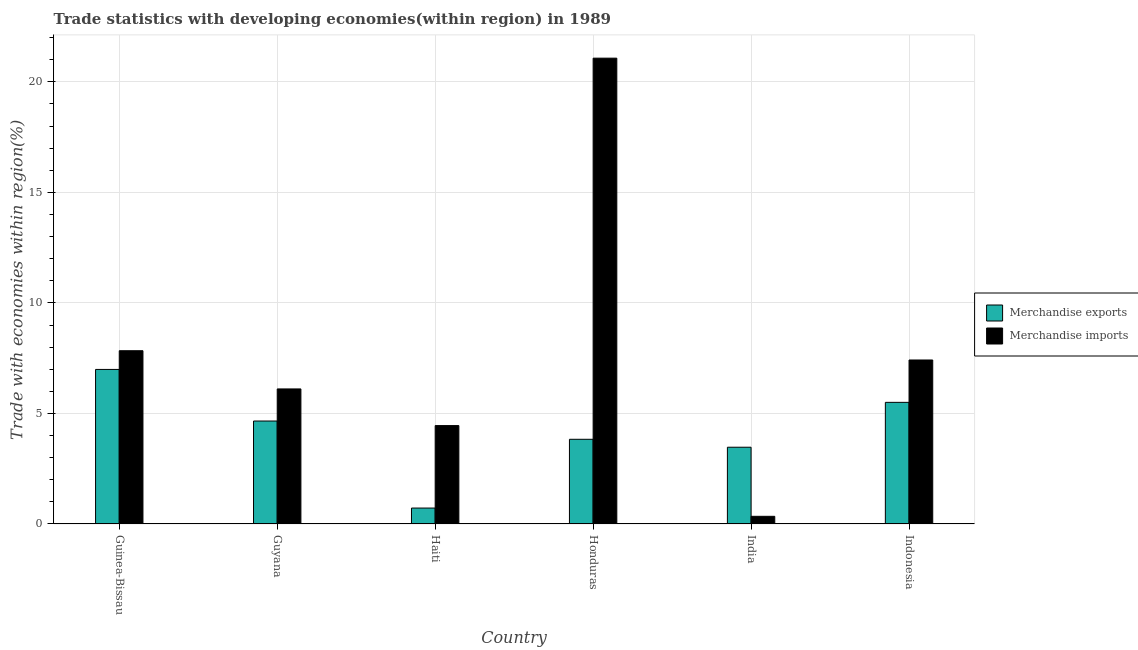Are the number of bars per tick equal to the number of legend labels?
Your response must be concise. Yes. How many bars are there on the 4th tick from the left?
Keep it short and to the point. 2. What is the label of the 6th group of bars from the left?
Your response must be concise. Indonesia. What is the merchandise exports in Guyana?
Give a very brief answer. 4.66. Across all countries, what is the maximum merchandise exports?
Your response must be concise. 6.99. Across all countries, what is the minimum merchandise exports?
Give a very brief answer. 0.72. In which country was the merchandise exports maximum?
Provide a short and direct response. Guinea-Bissau. In which country was the merchandise exports minimum?
Provide a succinct answer. Haiti. What is the total merchandise exports in the graph?
Ensure brevity in your answer.  25.17. What is the difference between the merchandise imports in Guyana and that in Haiti?
Offer a terse response. 1.66. What is the difference between the merchandise exports in Indonesia and the merchandise imports in Guinea-Bissau?
Make the answer very short. -2.34. What is the average merchandise imports per country?
Provide a short and direct response. 7.87. What is the difference between the merchandise imports and merchandise exports in Indonesia?
Your response must be concise. 1.92. What is the ratio of the merchandise imports in Guinea-Bissau to that in Haiti?
Offer a very short reply. 1.76. Is the difference between the merchandise exports in Haiti and Indonesia greater than the difference between the merchandise imports in Haiti and Indonesia?
Keep it short and to the point. No. What is the difference between the highest and the second highest merchandise imports?
Your response must be concise. 13.23. What is the difference between the highest and the lowest merchandise imports?
Provide a short and direct response. 20.72. Is the sum of the merchandise exports in India and Indonesia greater than the maximum merchandise imports across all countries?
Ensure brevity in your answer.  No. How many bars are there?
Your answer should be very brief. 12. Does the graph contain any zero values?
Keep it short and to the point. No. Does the graph contain grids?
Make the answer very short. Yes. Where does the legend appear in the graph?
Give a very brief answer. Center right. What is the title of the graph?
Your response must be concise. Trade statistics with developing economies(within region) in 1989. Does "Male labor force" appear as one of the legend labels in the graph?
Make the answer very short. No. What is the label or title of the X-axis?
Make the answer very short. Country. What is the label or title of the Y-axis?
Make the answer very short. Trade with economies within region(%). What is the Trade with economies within region(%) of Merchandise exports in Guinea-Bissau?
Ensure brevity in your answer.  6.99. What is the Trade with economies within region(%) of Merchandise imports in Guinea-Bissau?
Provide a short and direct response. 7.84. What is the Trade with economies within region(%) of Merchandise exports in Guyana?
Your answer should be very brief. 4.66. What is the Trade with economies within region(%) in Merchandise imports in Guyana?
Provide a short and direct response. 6.11. What is the Trade with economies within region(%) in Merchandise exports in Haiti?
Make the answer very short. 0.72. What is the Trade with economies within region(%) in Merchandise imports in Haiti?
Offer a terse response. 4.45. What is the Trade with economies within region(%) in Merchandise exports in Honduras?
Provide a short and direct response. 3.83. What is the Trade with economies within region(%) in Merchandise imports in Honduras?
Make the answer very short. 21.07. What is the Trade with economies within region(%) of Merchandise exports in India?
Your answer should be very brief. 3.47. What is the Trade with economies within region(%) of Merchandise imports in India?
Your answer should be compact. 0.35. What is the Trade with economies within region(%) in Merchandise exports in Indonesia?
Your answer should be compact. 5.5. What is the Trade with economies within region(%) of Merchandise imports in Indonesia?
Your answer should be compact. 7.42. Across all countries, what is the maximum Trade with economies within region(%) in Merchandise exports?
Provide a succinct answer. 6.99. Across all countries, what is the maximum Trade with economies within region(%) in Merchandise imports?
Your response must be concise. 21.07. Across all countries, what is the minimum Trade with economies within region(%) of Merchandise exports?
Offer a very short reply. 0.72. Across all countries, what is the minimum Trade with economies within region(%) in Merchandise imports?
Offer a very short reply. 0.35. What is the total Trade with economies within region(%) in Merchandise exports in the graph?
Your response must be concise. 25.17. What is the total Trade with economies within region(%) in Merchandise imports in the graph?
Ensure brevity in your answer.  47.23. What is the difference between the Trade with economies within region(%) of Merchandise exports in Guinea-Bissau and that in Guyana?
Give a very brief answer. 2.33. What is the difference between the Trade with economies within region(%) in Merchandise imports in Guinea-Bissau and that in Guyana?
Provide a succinct answer. 1.73. What is the difference between the Trade with economies within region(%) of Merchandise exports in Guinea-Bissau and that in Haiti?
Your response must be concise. 6.27. What is the difference between the Trade with economies within region(%) in Merchandise imports in Guinea-Bissau and that in Haiti?
Ensure brevity in your answer.  3.39. What is the difference between the Trade with economies within region(%) of Merchandise exports in Guinea-Bissau and that in Honduras?
Provide a succinct answer. 3.16. What is the difference between the Trade with economies within region(%) of Merchandise imports in Guinea-Bissau and that in Honduras?
Your response must be concise. -13.23. What is the difference between the Trade with economies within region(%) in Merchandise exports in Guinea-Bissau and that in India?
Provide a succinct answer. 3.52. What is the difference between the Trade with economies within region(%) in Merchandise imports in Guinea-Bissau and that in India?
Make the answer very short. 7.49. What is the difference between the Trade with economies within region(%) in Merchandise exports in Guinea-Bissau and that in Indonesia?
Offer a very short reply. 1.49. What is the difference between the Trade with economies within region(%) of Merchandise imports in Guinea-Bissau and that in Indonesia?
Offer a terse response. 0.42. What is the difference between the Trade with economies within region(%) of Merchandise exports in Guyana and that in Haiti?
Make the answer very short. 3.94. What is the difference between the Trade with economies within region(%) of Merchandise imports in Guyana and that in Haiti?
Give a very brief answer. 1.66. What is the difference between the Trade with economies within region(%) in Merchandise exports in Guyana and that in Honduras?
Give a very brief answer. 0.83. What is the difference between the Trade with economies within region(%) in Merchandise imports in Guyana and that in Honduras?
Your answer should be very brief. -14.96. What is the difference between the Trade with economies within region(%) in Merchandise exports in Guyana and that in India?
Your answer should be very brief. 1.19. What is the difference between the Trade with economies within region(%) of Merchandise imports in Guyana and that in India?
Your answer should be very brief. 5.76. What is the difference between the Trade with economies within region(%) of Merchandise exports in Guyana and that in Indonesia?
Ensure brevity in your answer.  -0.84. What is the difference between the Trade with economies within region(%) in Merchandise imports in Guyana and that in Indonesia?
Provide a short and direct response. -1.31. What is the difference between the Trade with economies within region(%) of Merchandise exports in Haiti and that in Honduras?
Provide a short and direct response. -3.11. What is the difference between the Trade with economies within region(%) of Merchandise imports in Haiti and that in Honduras?
Offer a very short reply. -16.62. What is the difference between the Trade with economies within region(%) of Merchandise exports in Haiti and that in India?
Give a very brief answer. -2.75. What is the difference between the Trade with economies within region(%) in Merchandise imports in Haiti and that in India?
Provide a short and direct response. 4.1. What is the difference between the Trade with economies within region(%) of Merchandise exports in Haiti and that in Indonesia?
Offer a very short reply. -4.78. What is the difference between the Trade with economies within region(%) of Merchandise imports in Haiti and that in Indonesia?
Make the answer very short. -2.97. What is the difference between the Trade with economies within region(%) in Merchandise exports in Honduras and that in India?
Your answer should be compact. 0.36. What is the difference between the Trade with economies within region(%) in Merchandise imports in Honduras and that in India?
Offer a very short reply. 20.72. What is the difference between the Trade with economies within region(%) in Merchandise exports in Honduras and that in Indonesia?
Offer a terse response. -1.67. What is the difference between the Trade with economies within region(%) of Merchandise imports in Honduras and that in Indonesia?
Your answer should be very brief. 13.65. What is the difference between the Trade with economies within region(%) in Merchandise exports in India and that in Indonesia?
Give a very brief answer. -2.03. What is the difference between the Trade with economies within region(%) in Merchandise imports in India and that in Indonesia?
Your answer should be compact. -7.07. What is the difference between the Trade with economies within region(%) in Merchandise exports in Guinea-Bissau and the Trade with economies within region(%) in Merchandise imports in Guyana?
Provide a short and direct response. 0.88. What is the difference between the Trade with economies within region(%) of Merchandise exports in Guinea-Bissau and the Trade with economies within region(%) of Merchandise imports in Haiti?
Offer a very short reply. 2.54. What is the difference between the Trade with economies within region(%) of Merchandise exports in Guinea-Bissau and the Trade with economies within region(%) of Merchandise imports in Honduras?
Your response must be concise. -14.08. What is the difference between the Trade with economies within region(%) of Merchandise exports in Guinea-Bissau and the Trade with economies within region(%) of Merchandise imports in India?
Make the answer very short. 6.64. What is the difference between the Trade with economies within region(%) of Merchandise exports in Guinea-Bissau and the Trade with economies within region(%) of Merchandise imports in Indonesia?
Ensure brevity in your answer.  -0.43. What is the difference between the Trade with economies within region(%) in Merchandise exports in Guyana and the Trade with economies within region(%) in Merchandise imports in Haiti?
Provide a succinct answer. 0.21. What is the difference between the Trade with economies within region(%) in Merchandise exports in Guyana and the Trade with economies within region(%) in Merchandise imports in Honduras?
Your response must be concise. -16.41. What is the difference between the Trade with economies within region(%) in Merchandise exports in Guyana and the Trade with economies within region(%) in Merchandise imports in India?
Make the answer very short. 4.31. What is the difference between the Trade with economies within region(%) in Merchandise exports in Guyana and the Trade with economies within region(%) in Merchandise imports in Indonesia?
Give a very brief answer. -2.76. What is the difference between the Trade with economies within region(%) in Merchandise exports in Haiti and the Trade with economies within region(%) in Merchandise imports in Honduras?
Ensure brevity in your answer.  -20.35. What is the difference between the Trade with economies within region(%) of Merchandise exports in Haiti and the Trade with economies within region(%) of Merchandise imports in India?
Your answer should be compact. 0.37. What is the difference between the Trade with economies within region(%) in Merchandise exports in Haiti and the Trade with economies within region(%) in Merchandise imports in Indonesia?
Your answer should be compact. -6.7. What is the difference between the Trade with economies within region(%) in Merchandise exports in Honduras and the Trade with economies within region(%) in Merchandise imports in India?
Offer a terse response. 3.48. What is the difference between the Trade with economies within region(%) of Merchandise exports in Honduras and the Trade with economies within region(%) of Merchandise imports in Indonesia?
Make the answer very short. -3.59. What is the difference between the Trade with economies within region(%) in Merchandise exports in India and the Trade with economies within region(%) in Merchandise imports in Indonesia?
Provide a short and direct response. -3.95. What is the average Trade with economies within region(%) of Merchandise exports per country?
Offer a terse response. 4.2. What is the average Trade with economies within region(%) of Merchandise imports per country?
Your response must be concise. 7.87. What is the difference between the Trade with economies within region(%) in Merchandise exports and Trade with economies within region(%) in Merchandise imports in Guinea-Bissau?
Keep it short and to the point. -0.85. What is the difference between the Trade with economies within region(%) in Merchandise exports and Trade with economies within region(%) in Merchandise imports in Guyana?
Provide a short and direct response. -1.45. What is the difference between the Trade with economies within region(%) of Merchandise exports and Trade with economies within region(%) of Merchandise imports in Haiti?
Ensure brevity in your answer.  -3.73. What is the difference between the Trade with economies within region(%) of Merchandise exports and Trade with economies within region(%) of Merchandise imports in Honduras?
Your answer should be very brief. -17.24. What is the difference between the Trade with economies within region(%) in Merchandise exports and Trade with economies within region(%) in Merchandise imports in India?
Keep it short and to the point. 3.12. What is the difference between the Trade with economies within region(%) of Merchandise exports and Trade with economies within region(%) of Merchandise imports in Indonesia?
Provide a short and direct response. -1.92. What is the ratio of the Trade with economies within region(%) of Merchandise exports in Guinea-Bissau to that in Guyana?
Ensure brevity in your answer.  1.5. What is the ratio of the Trade with economies within region(%) of Merchandise imports in Guinea-Bissau to that in Guyana?
Make the answer very short. 1.28. What is the ratio of the Trade with economies within region(%) in Merchandise exports in Guinea-Bissau to that in Haiti?
Your response must be concise. 9.7. What is the ratio of the Trade with economies within region(%) in Merchandise imports in Guinea-Bissau to that in Haiti?
Give a very brief answer. 1.76. What is the ratio of the Trade with economies within region(%) of Merchandise exports in Guinea-Bissau to that in Honduras?
Your answer should be very brief. 1.82. What is the ratio of the Trade with economies within region(%) of Merchandise imports in Guinea-Bissau to that in Honduras?
Make the answer very short. 0.37. What is the ratio of the Trade with economies within region(%) of Merchandise exports in Guinea-Bissau to that in India?
Offer a very short reply. 2.01. What is the ratio of the Trade with economies within region(%) in Merchandise imports in Guinea-Bissau to that in India?
Ensure brevity in your answer.  22.61. What is the ratio of the Trade with economies within region(%) in Merchandise exports in Guinea-Bissau to that in Indonesia?
Offer a terse response. 1.27. What is the ratio of the Trade with economies within region(%) in Merchandise imports in Guinea-Bissau to that in Indonesia?
Make the answer very short. 1.06. What is the ratio of the Trade with economies within region(%) in Merchandise exports in Guyana to that in Haiti?
Ensure brevity in your answer.  6.46. What is the ratio of the Trade with economies within region(%) in Merchandise imports in Guyana to that in Haiti?
Make the answer very short. 1.37. What is the ratio of the Trade with economies within region(%) of Merchandise exports in Guyana to that in Honduras?
Provide a succinct answer. 1.22. What is the ratio of the Trade with economies within region(%) in Merchandise imports in Guyana to that in Honduras?
Provide a short and direct response. 0.29. What is the ratio of the Trade with economies within region(%) in Merchandise exports in Guyana to that in India?
Give a very brief answer. 1.34. What is the ratio of the Trade with economies within region(%) of Merchandise imports in Guyana to that in India?
Give a very brief answer. 17.62. What is the ratio of the Trade with economies within region(%) of Merchandise exports in Guyana to that in Indonesia?
Your answer should be compact. 0.85. What is the ratio of the Trade with economies within region(%) in Merchandise imports in Guyana to that in Indonesia?
Give a very brief answer. 0.82. What is the ratio of the Trade with economies within region(%) of Merchandise exports in Haiti to that in Honduras?
Offer a very short reply. 0.19. What is the ratio of the Trade with economies within region(%) of Merchandise imports in Haiti to that in Honduras?
Your answer should be compact. 0.21. What is the ratio of the Trade with economies within region(%) of Merchandise exports in Haiti to that in India?
Offer a terse response. 0.21. What is the ratio of the Trade with economies within region(%) in Merchandise imports in Haiti to that in India?
Offer a very short reply. 12.84. What is the ratio of the Trade with economies within region(%) of Merchandise exports in Haiti to that in Indonesia?
Provide a succinct answer. 0.13. What is the ratio of the Trade with economies within region(%) of Merchandise imports in Haiti to that in Indonesia?
Give a very brief answer. 0.6. What is the ratio of the Trade with economies within region(%) in Merchandise exports in Honduras to that in India?
Make the answer very short. 1.1. What is the ratio of the Trade with economies within region(%) of Merchandise imports in Honduras to that in India?
Offer a very short reply. 60.78. What is the ratio of the Trade with economies within region(%) of Merchandise exports in Honduras to that in Indonesia?
Your answer should be very brief. 0.7. What is the ratio of the Trade with economies within region(%) in Merchandise imports in Honduras to that in Indonesia?
Give a very brief answer. 2.84. What is the ratio of the Trade with economies within region(%) of Merchandise exports in India to that in Indonesia?
Offer a terse response. 0.63. What is the ratio of the Trade with economies within region(%) of Merchandise imports in India to that in Indonesia?
Give a very brief answer. 0.05. What is the difference between the highest and the second highest Trade with economies within region(%) of Merchandise exports?
Your answer should be compact. 1.49. What is the difference between the highest and the second highest Trade with economies within region(%) in Merchandise imports?
Ensure brevity in your answer.  13.23. What is the difference between the highest and the lowest Trade with economies within region(%) of Merchandise exports?
Make the answer very short. 6.27. What is the difference between the highest and the lowest Trade with economies within region(%) in Merchandise imports?
Offer a terse response. 20.72. 